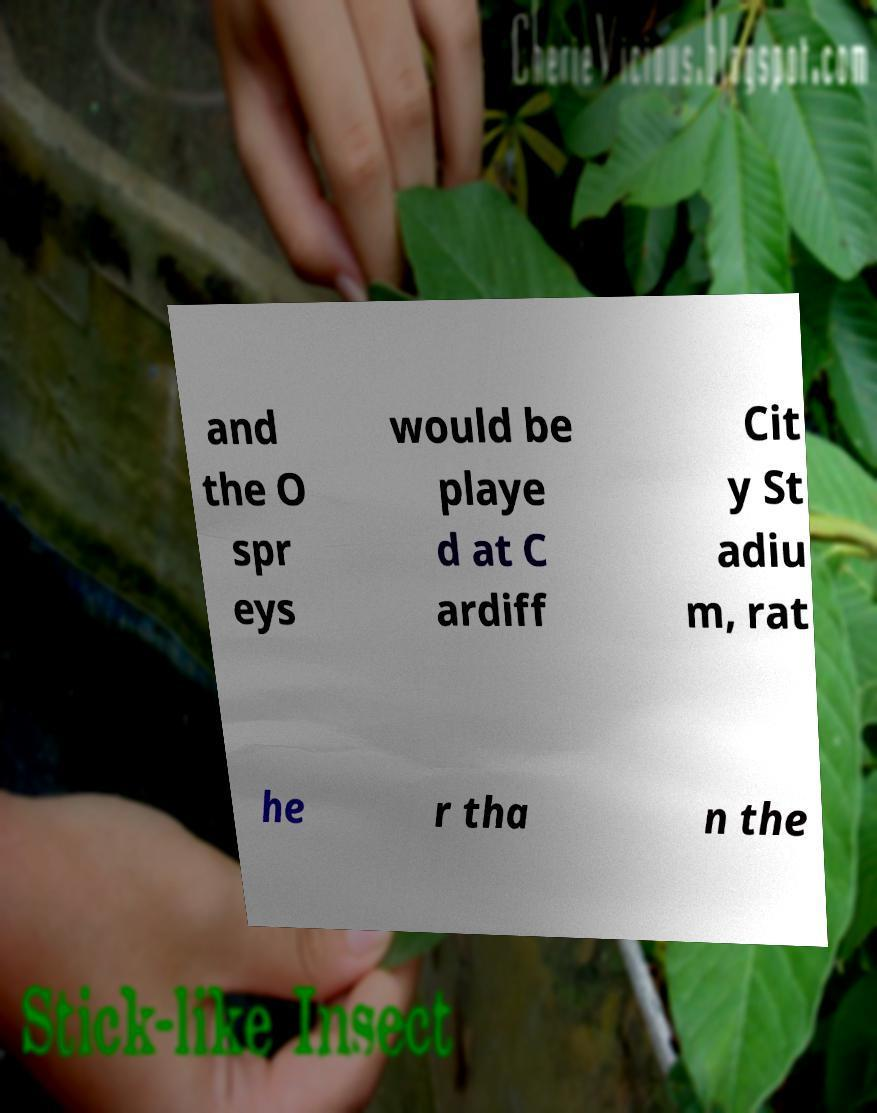Please read and relay the text visible in this image. What does it say? and the O spr eys would be playe d at C ardiff Cit y St adiu m, rat he r tha n the 